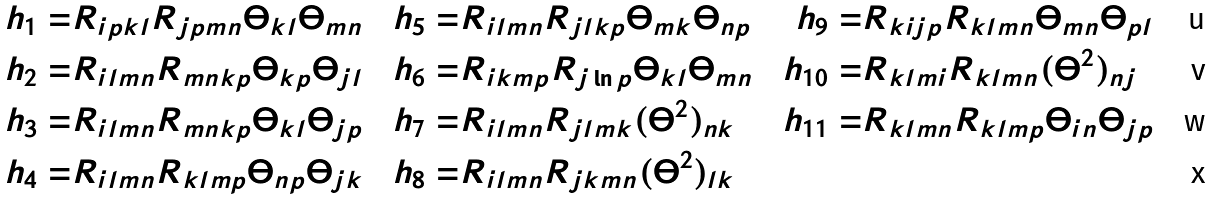Convert formula to latex. <formula><loc_0><loc_0><loc_500><loc_500>h _ { 1 } = & R _ { i p k l } R _ { j p m n } \Theta _ { k l } \Theta _ { m n } & h _ { 5 } = & R _ { i l m n } R _ { j l k p } \Theta _ { m k } \Theta _ { n p } & h _ { 9 } = & R _ { k i j p } R _ { k l m n } \Theta _ { m n } \Theta _ { p l } \\ h _ { 2 } = & R _ { i l m n } R _ { m n k p } \Theta _ { k p } \Theta _ { j l } & h _ { 6 } = & R _ { i k m p } R _ { j \ln p } \Theta _ { k l } \Theta _ { m n } & h _ { 1 0 } = & R _ { k l m i } R _ { k l m n } ( \Theta ^ { 2 } ) _ { n j } \\ h _ { 3 } = & R _ { i l m n } R _ { m n k p } \Theta _ { k l } \Theta _ { j p } & h _ { 7 } = & R _ { i l m n } R _ { j l m k } ( \Theta ^ { 2 } ) _ { n k } & h _ { 1 1 } = & R _ { k l m n } R _ { k l m p } \Theta _ { i n } \Theta _ { j p } \\ h _ { 4 } = & R _ { i l m n } R _ { k l m p } \Theta _ { n p } \Theta _ { j k } & h _ { 8 } = & R _ { i l m n } R _ { j k m n } ( \Theta ^ { 2 } ) _ { l k }</formula> 